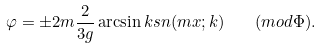<formula> <loc_0><loc_0><loc_500><loc_500>\varphi = \pm 2 m \frac { 2 } { 3 g } \arcsin { k s n ( m x ; k ) } \quad ( m o d \Phi ) .</formula> 